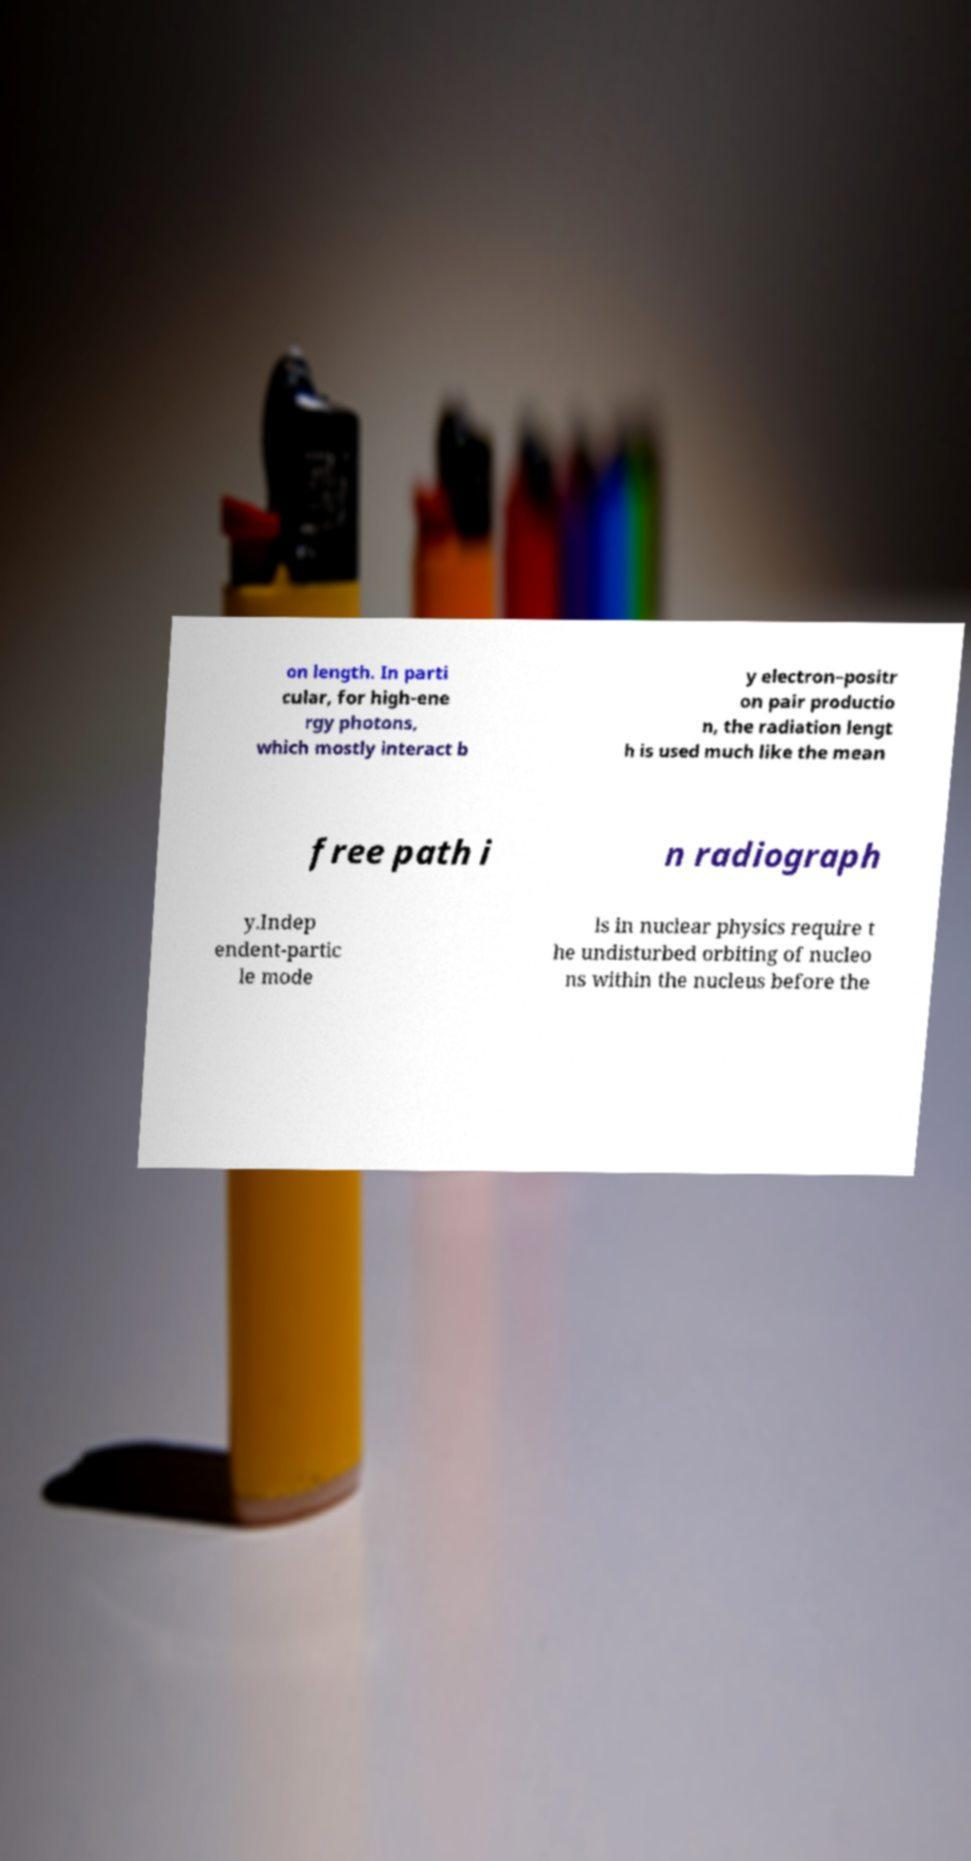Can you read and provide the text displayed in the image?This photo seems to have some interesting text. Can you extract and type it out for me? on length. In parti cular, for high-ene rgy photons, which mostly interact b y electron–positr on pair productio n, the radiation lengt h is used much like the mean free path i n radiograph y.Indep endent-partic le mode ls in nuclear physics require t he undisturbed orbiting of nucleo ns within the nucleus before the 